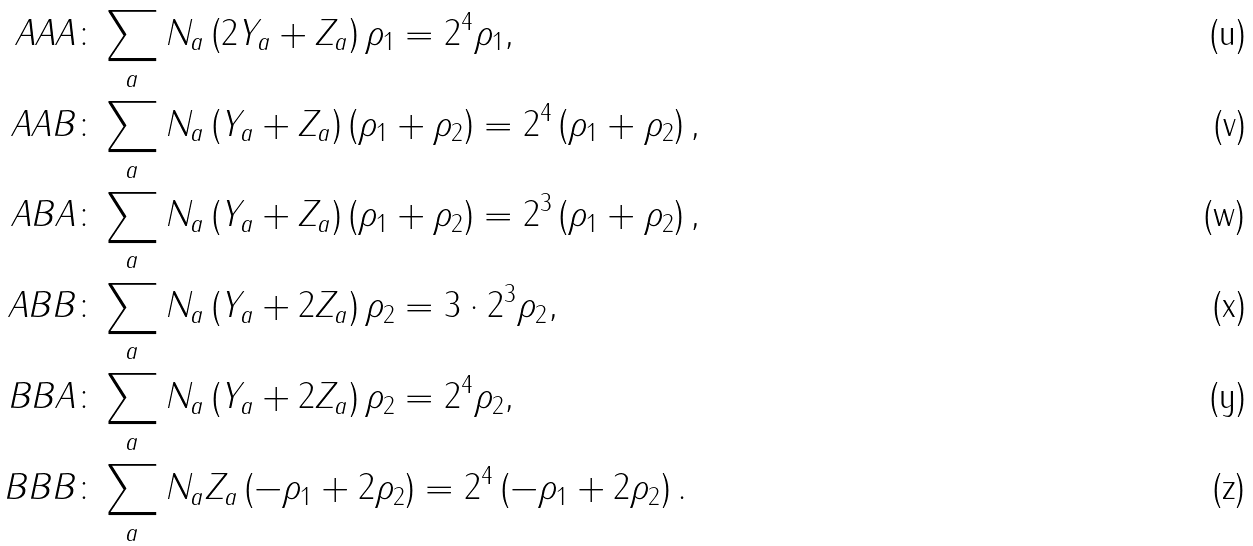<formula> <loc_0><loc_0><loc_500><loc_500>{ A A A \colon } & \sum _ { a } N _ { a } \left ( 2 Y _ { a } + Z _ { a } \right ) \rho _ { 1 } = 2 ^ { 4 } \rho _ { 1 } , \\ { A A B \colon } & \sum _ { a } N _ { a } \left ( Y _ { a } + Z _ { a } \right ) \left ( \rho _ { 1 } + \rho _ { 2 } \right ) = 2 ^ { 4 } \left ( \rho _ { 1 } + \rho _ { 2 } \right ) , \\ { A B A \colon } & \sum _ { a } N _ { a } \left ( Y _ { a } + Z _ { a } \right ) \left ( \rho _ { 1 } + \rho _ { 2 } \right ) = 2 ^ { 3 } \left ( \rho _ { 1 } + \rho _ { 2 } \right ) , \\ { A B B \colon } & \sum _ { a } N _ { a } \left ( Y _ { a } + 2 Z _ { a } \right ) \rho _ { 2 } = 3 \cdot 2 ^ { 3 } \rho _ { 2 } , \\ { B B A \colon } & \sum _ { a } N _ { a } \left ( Y _ { a } + 2 Z _ { a } \right ) \rho _ { 2 } = 2 ^ { 4 } \rho _ { 2 } , \\ { B B B \colon } & \sum _ { a } N _ { a } Z _ { a } \left ( - \rho _ { 1 } + 2 \rho _ { 2 } \right ) = 2 ^ { 4 } \left ( - \rho _ { 1 } + 2 \rho _ { 2 } \right ) .</formula> 